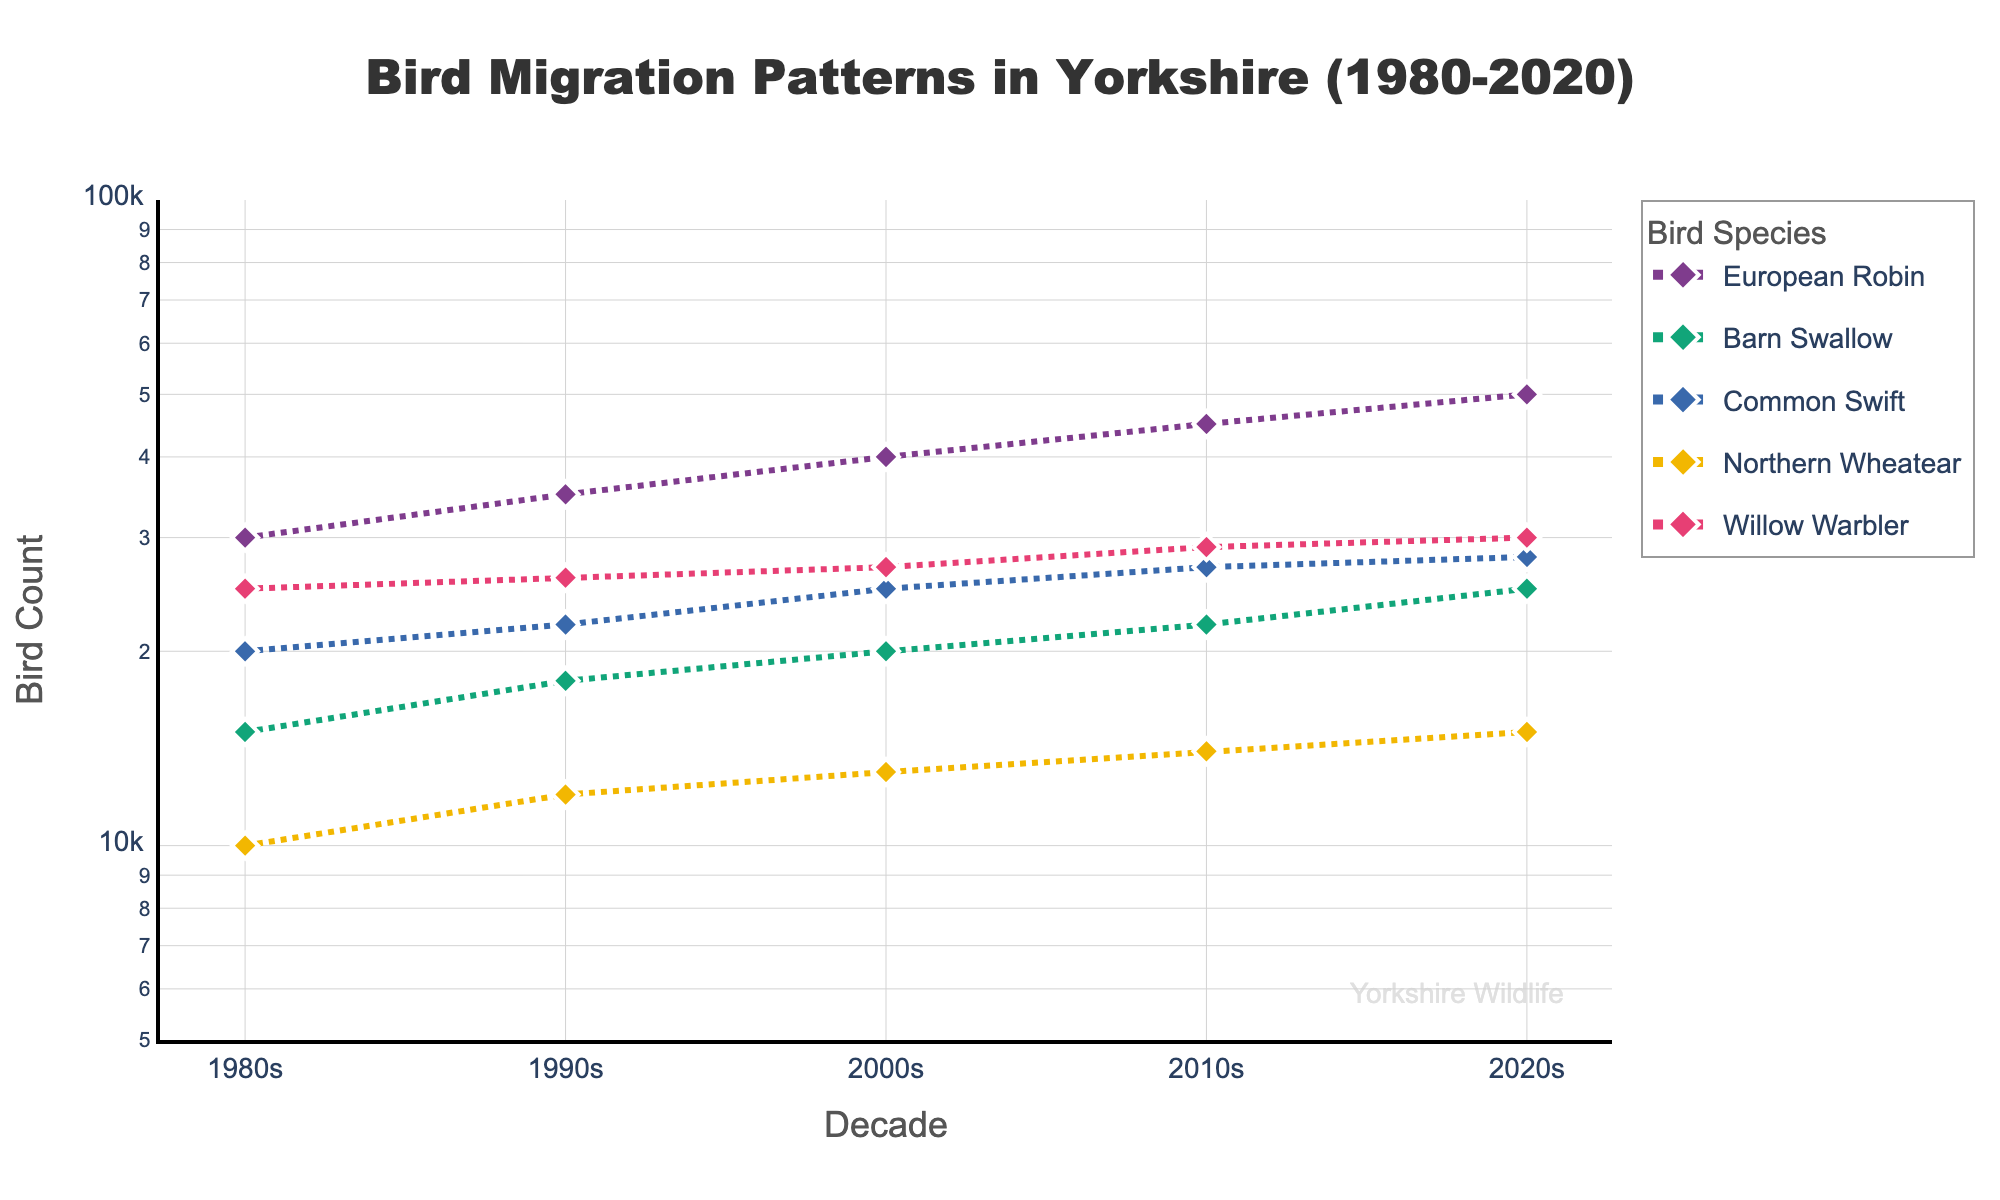How many species are represented in the plot? There are distinct lines and markers for each bird species in the plot. By counting them, you can identify the species represented.
Answer: 5 What is the title of the figure? The title is usually located at the top of the plot and provides a concise description of the visualized data.
Answer: Bird Migration Patterns in Yorkshire (1980-2020) During which decade did the Willow Warbler's count exceed 25,000? Follow the line and markers for the Willow Warbler and check the y-axis values across decades.
Answer: 1990s By how much did the Northern Wheatear’s population increase from 1980 to 2020? Follow the markers for Northern Wheatear on the y-axis for 1980 and 2020, then calculate the difference. 15,000 - 10,000 = 5,000.
Answer: 5,000 Which species had the lowest count in the 1980s? Find each species' marker for the 1980 decade and check the y-axis values to find the smallest count.
Answer: Northern Wheatear Which species shows the most significant growth from 1980 to 2020? By examining the slopes of the lines from 1980 to 2020 for each species, the species with the steepest slope indicates the most significant growth.
Answer: European Robin What is the bird count for the Common Swift in the 2010s? Check the y-axis value corresponding to the marker for Common Swift in the 2010 decade.
Answer: 27,000 How does the log scale affect the perception of bird population changes? On a log scale, equal distances represent multiplicative changes, which can make small changes in data apparent and large changes less pronounced.
Answer: It normalizes differences Which species appears to have reached a plateau in population growth? A species with a line that flattens out over decades indicates little to no population growth.
Answer: Common Swift Between the 1980s and 1990s, which species showed the highest relative increase in population? Calculate the relative increase for each species ((count in 1990 - count in 1980) / count in 1980), then identify the highest value.
Answer: Northern Wheatear 